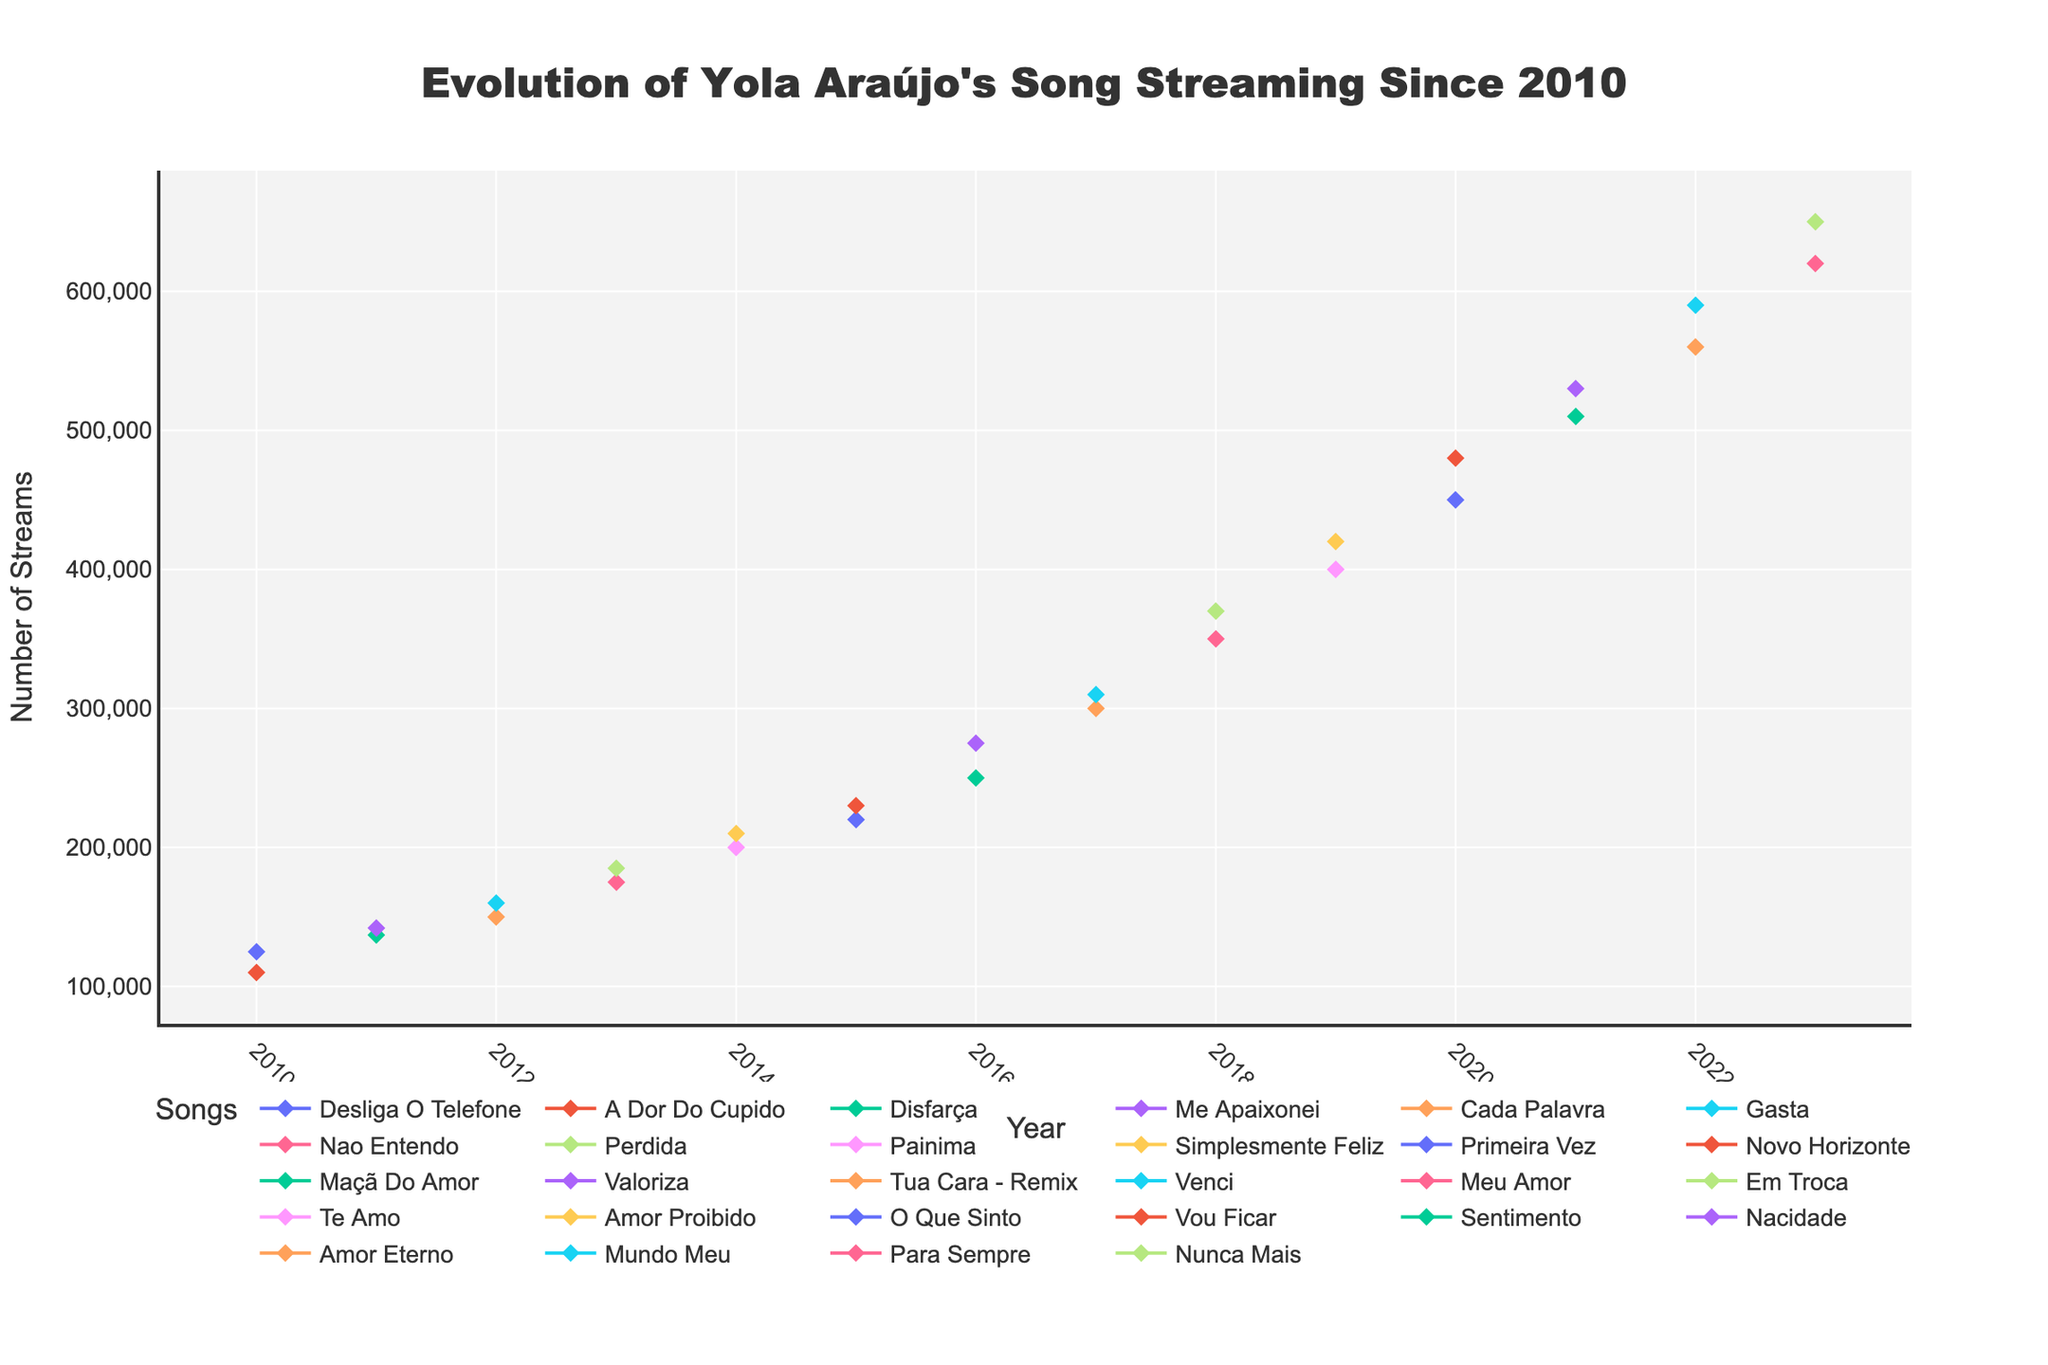What is the title of the figure? The title is usually located at the top of the figure. In this case, it reads "Evolution of Yola Araújo's Song Streaming Since 2010."
Answer: Evolution of Yola Araújo's Song Streaming Since 2010 Which year had the song with the highest number of streams? By looking at the plot, you can see that the peak of the streaming data reaches 650,000 streams in 2023 for the song "Nunca Mais."
Answer: 2023 How many songs were released in 2015? To find the count of data points for 2015, check the x-axis labels for 2015 and count the corresponding markers. There are two markers for "Primeira Vez" and "Novo Horizonte."
Answer: 2 What song had the highest number of streams in 2017 and how many streams did it have? For 2017, comparing the data points, "Venci" has more streams than "Tua Cara - Remix," with 310,000 streams.
Answer: Venci, 310,000 How did the number of streams for "Sentimento" change from 2020 to 2021? Identify the data points for "Sentimento" in 2020 and 2021 on the plot. In 2020, it had 450,000, and in 2021, it had 510,000 streams. The increase is 510,000 - 450,000 = 60,000 streams.
Answer: Increased by 60,000 Which song showed the most significant increase in streams between consecutive years, and what was the increase? Compare the differences in streams for each song between consecutive years. The largest increase is from "Vou Ficar" (2020 - 480,000) to "Sentimento" (2021 - 510,000) with an increase of 30,000 streams.
Answer: Vou Ficar, 30,000 How many songs were released in both 2018 and 2022? Count the number of markers corresponding to 2018 and 2022 on the x-axis. Each year has two songs: "Meu Amor" and "Em Troca" for 2018, and "Amor Eterno" and "Mundo Meu" for 2022.
Answer: 2 songs per year Were there any years without a song release? If so, which years? By scanning the x-axis for any gaps in the continuous markers, you can determine that each year from 2010 to 2023 has at least one song released, meaning there are no gaps.
Answer: No What is the general trend for Yola Araújo's streaming numbers over the years? Observing the overall trend of the data points, the streaming numbers show a positive upward trend from 2010 to 2023.
Answer: Positive upward trend 